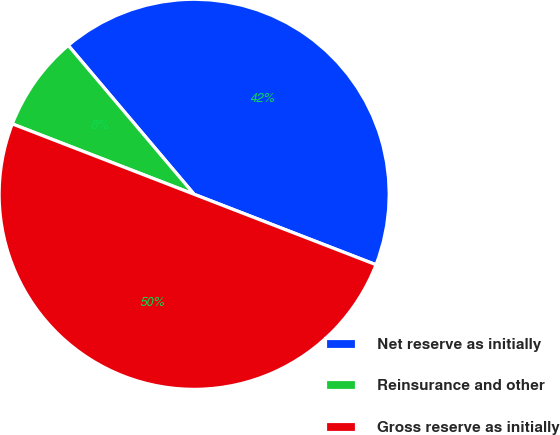<chart> <loc_0><loc_0><loc_500><loc_500><pie_chart><fcel>Net reserve as initially<fcel>Reinsurance and other<fcel>Gross reserve as initially<nl><fcel>42.05%<fcel>7.95%<fcel>50.0%<nl></chart> 